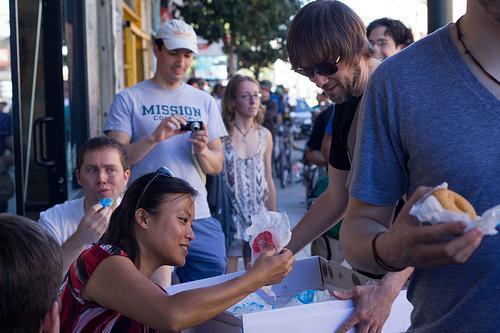How many clearly visible people are depicted?
Give a very brief answer. 7. 